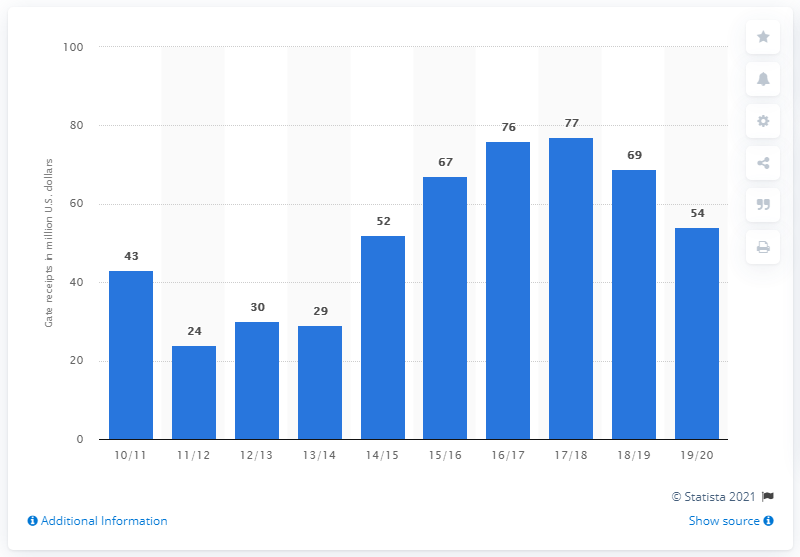List a handful of essential elements in this visual. The gate receipts of the Cleveland Cavaliers for the 2019/20 season were $54 million. 